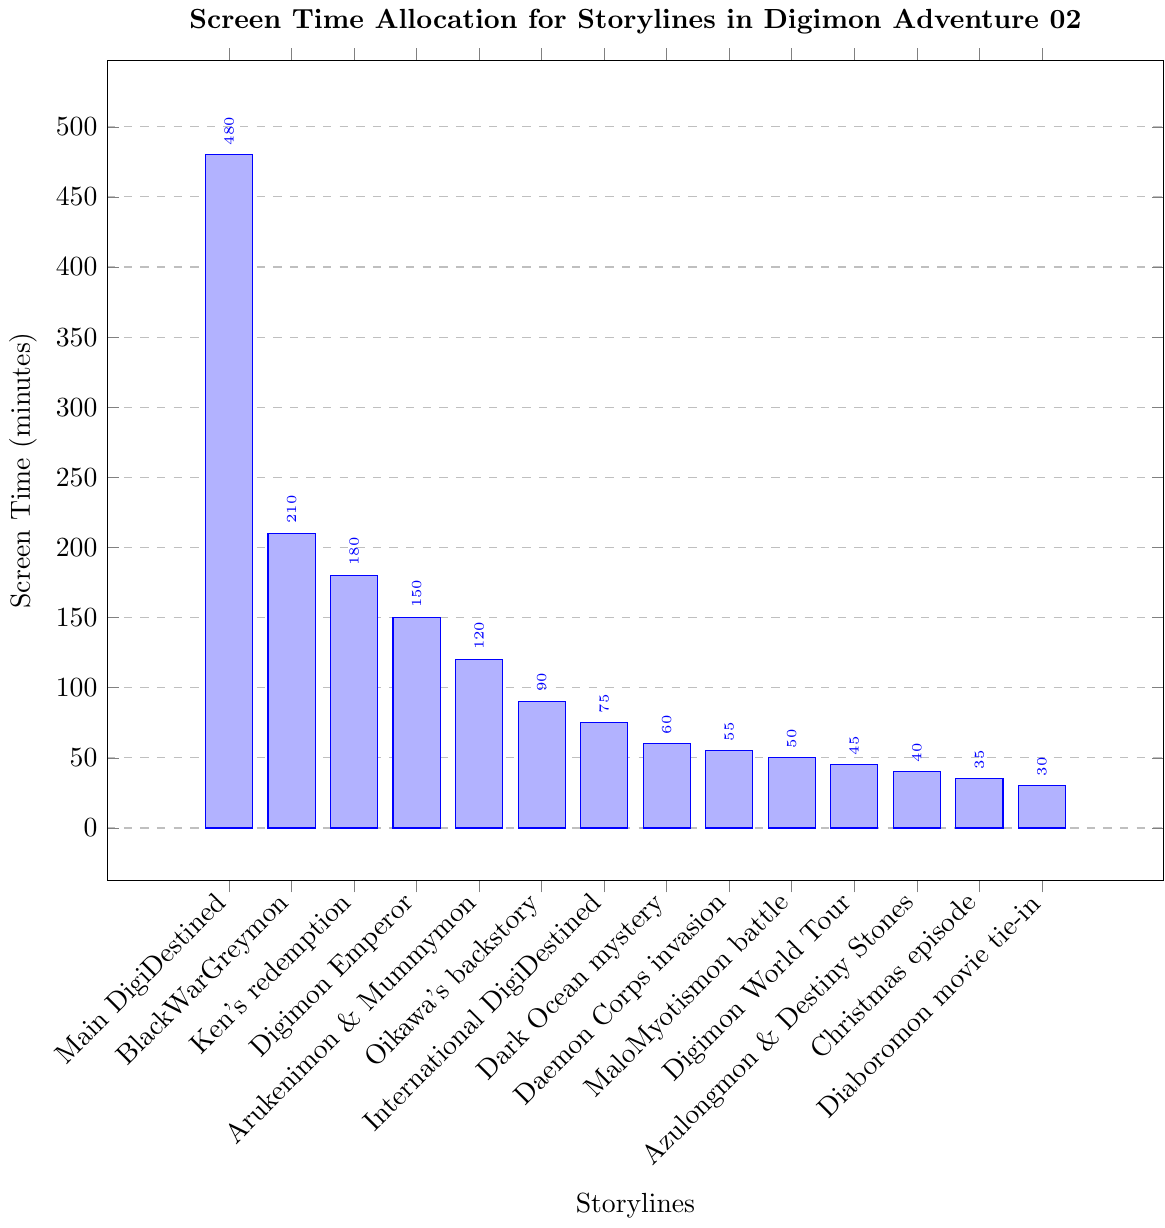Which storyline has the highest screen time? The tallest bar represents the storyline with the highest screen time. This bar corresponds to "Main DigiDestined plot."
Answer: Main DigiDestined plot What's the difference in screen time between the Main DigiDestined plot and the BlackWarGreymon arc? The screen time for the Main DigiDestined plot is 480 minutes, and for the BlackWarGreymon arc, it's 210 minutes. The difference is 480 - 210 = 270 minutes.
Answer: 270 minutes What's the average screen time of the bottom three storylines? The screen times for the bottom three storylines are 40 minutes (Azulongmon and Destiny Stones), 35 minutes (Christmas episode), and 30 minutes (Revenge of Diaboromon movie tie-in). The average is (40 + 35 + 30) / 3 = 105 / 3 = 35 minutes.
Answer: 35 minutes Which storyline has greater screen time: Ken's redemption or the Digimon Emperor arc? Comparing the heights of the bars for "Ken's redemption" (180 minutes) and "Digimon Emperor arc" (150 minutes), the "Ken's redemption" has the greater screen time.
Answer: Ken's redemption How much total screen time is allocated to the International DigiDestined, Dark Ocean mystery, and Daemon Corps invasion storylines combined? The screen times are 75 minutes (International DigiDestined), 60 minutes (Dark Ocean mystery), and 55 minutes (Daemon Corps invasion). The total is 75 + 60 + 55 = 190 minutes.
Answer: 190 minutes Among the storylines "Arukenimon and Mummymon subplot" and "Oikawa's backstory," which gets more screen time and by how much? "Arukenimon and Mummymon subplot" has 120 minutes, and "Oikawa's backstory" has 90 minutes. The difference is 120 - 90 = 30 minutes.
Answer: Arukenimon and Mummymon subplot by 30 minutes Which two storylines have an equal screen time length? By inspecting the heights of the bars, the storylines "Azulongmon and Destiny Stones" and "Christmas episode" looks equal, both having 40 minutes.
Answer: None 